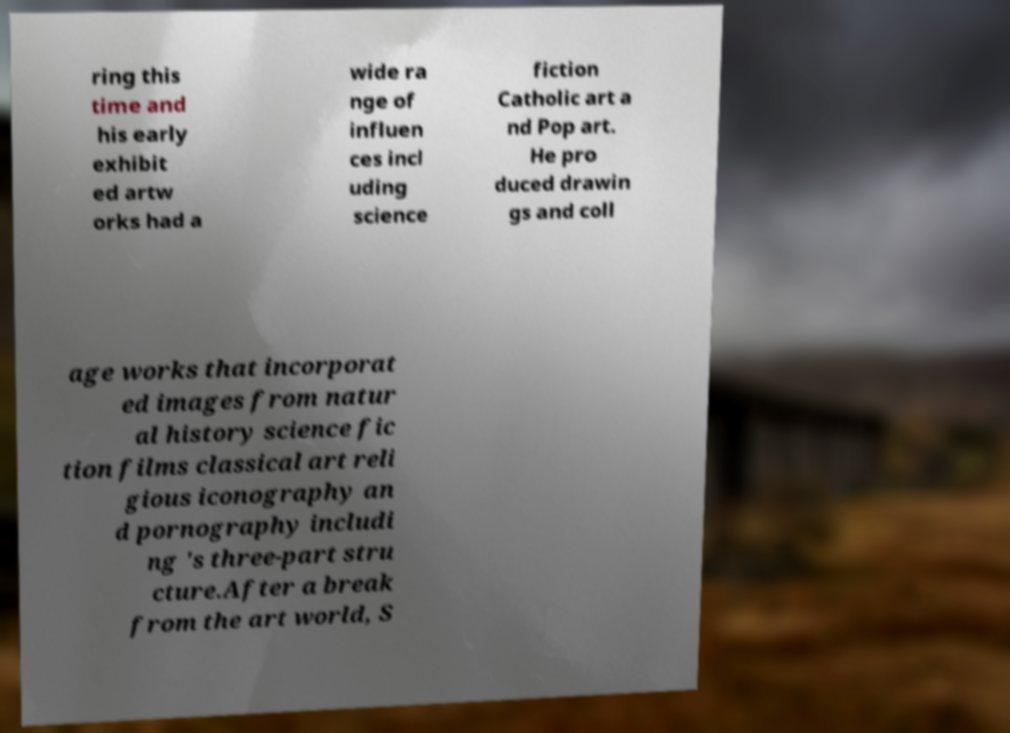Please identify and transcribe the text found in this image. ring this time and his early exhibit ed artw orks had a wide ra nge of influen ces incl uding science fiction Catholic art a nd Pop art. He pro duced drawin gs and coll age works that incorporat ed images from natur al history science fic tion films classical art reli gious iconography an d pornography includi ng 's three-part stru cture.After a break from the art world, S 